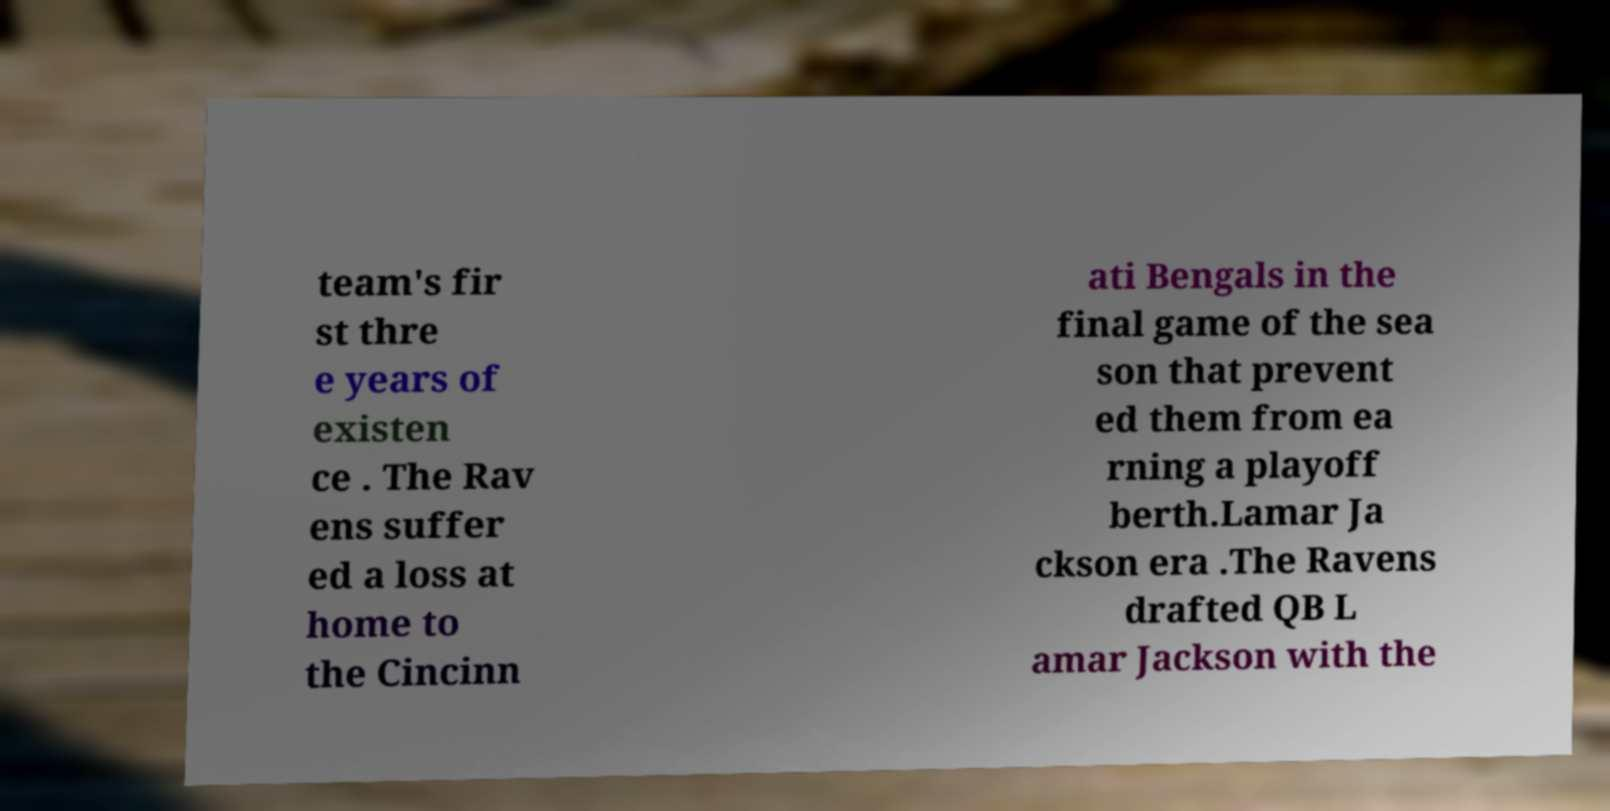There's text embedded in this image that I need extracted. Can you transcribe it verbatim? team's fir st thre e years of existen ce . The Rav ens suffer ed a loss at home to the Cincinn ati Bengals in the final game of the sea son that prevent ed them from ea rning a playoff berth.Lamar Ja ckson era .The Ravens drafted QB L amar Jackson with the 